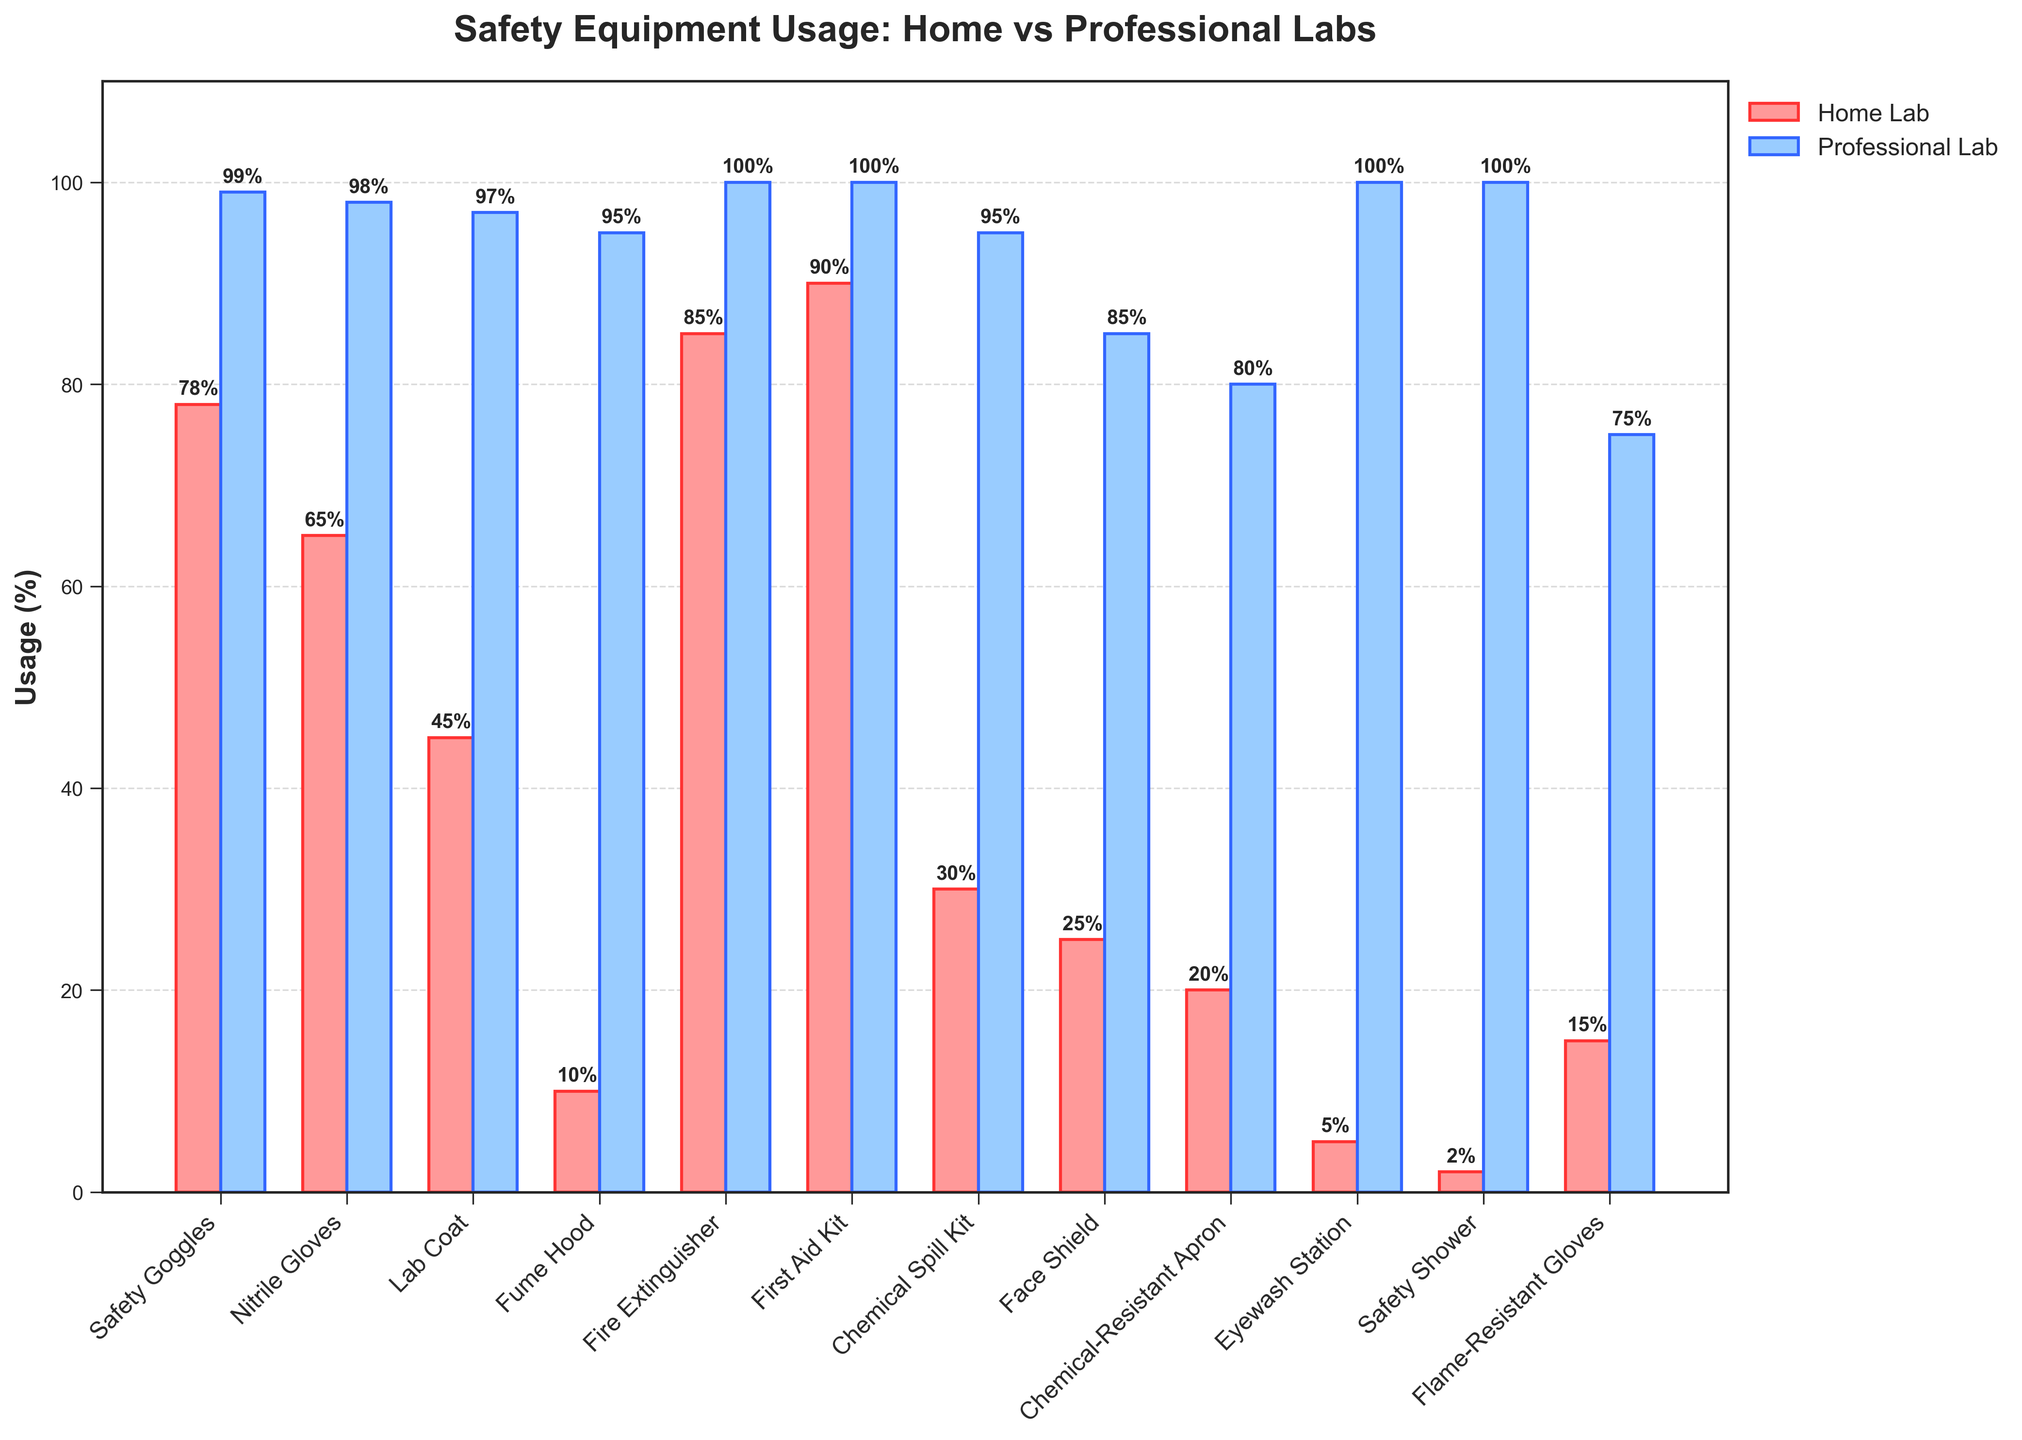What's the difference in usage percentage for Safety Goggles between home labs and professional labs? The bar for Safety Goggles shows 78% usage in home labs and 99% usage in professional labs. Subtracting these values gives 99% - 78% = 21%.
Answer: 21% Which piece of safety equipment has the largest difference in usage between home labs and professional labs? By comparing the difference in usage percentages for each piece of equipment, the Eyewash Station shows 5% usage in home labs and 100% in professional labs, resulting in a difference of 95%, which is the largest among all items.
Answer: Eyewash Station How many pieces of safety equipment are used by more than 90% of professional labs? By looking at the bars associated with professional labs, count the number of items with usage percentages above 90%. These include Safety Goggles, Nitrile Gloves, Lab Coat, Fume Hood, Fire Extinguisher, First Aid Kit, Chemical Spill Kit, Eyewash Station, and Safety Shower, totaling 9 items.
Answer: 9 What is the average usage percentage of Face Shield and Flame-Resistant Gloves in home labs? The usage percentages for Face Shield and Flame-Resistant Gloves in home labs are 25% and 15%, respectively. The average is calculated as (25% + 15%) / 2 = 20%.
Answer: 20% Which two pieces of safety equipment have the closest usage percentages in professional labs? By inspecting the bars in the professional labs category, the Chemical-Resistant Apron (80%) and Face Shield (85%) have the closest usage percentages, with a difference of 85% - 80% = 5%.
Answer: Face Shield and Chemical-Resistant Apron Is any safety equipment used equally in both home and professional labs? By comparing the usage percentages of all pieces of equipment in both categories, none of the items are used equally in home and professional labs.
Answer: No What percentage of home labs uses Fire Extinguishers and how does this compare to professional labs? Fire Extinguisher usage in home labs is 85%, while in professional labs it is 100%. Comparing these, professional labs have a higher usage by 100% - 85% = 15%.
Answer: 85% and professional labs use it 15% more Which safety equipment has the lowest usage percentage in both home and professional labs? For home labs, the Safety Shower has the lowest usage at 2%, and for professional labs, it is the same Safety Shower at 100%. Lowest usage across both categories is found in home labs with the Safety Shower at 2%.
Answer: Safety Shower (home labs) 